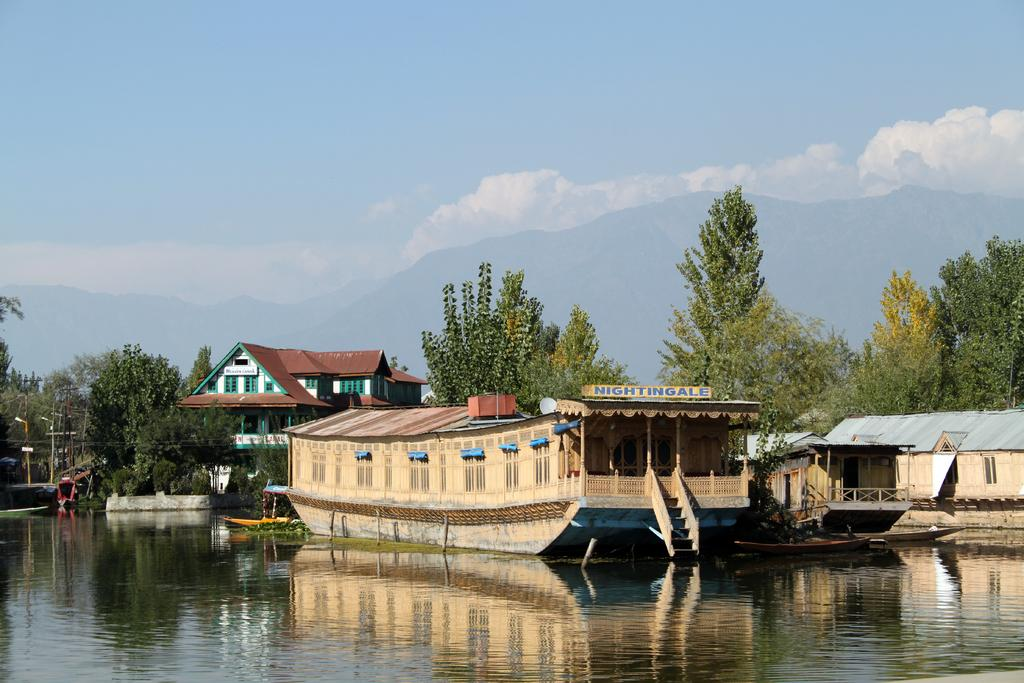What is on the water in the image? There are boats on the water in the image. What can be seen in the distance behind the boats? There are houses, trees, a railing, and current poles in the background of the image. What is the condition of the sky in the image? The sky is cloudy in the background of the image. What type of trousers are the sheep wearing in the image? There are no sheep or trousers present in the image. Where is the pocket located on the boat in the image? There are no pockets visible on the boats in the image. 